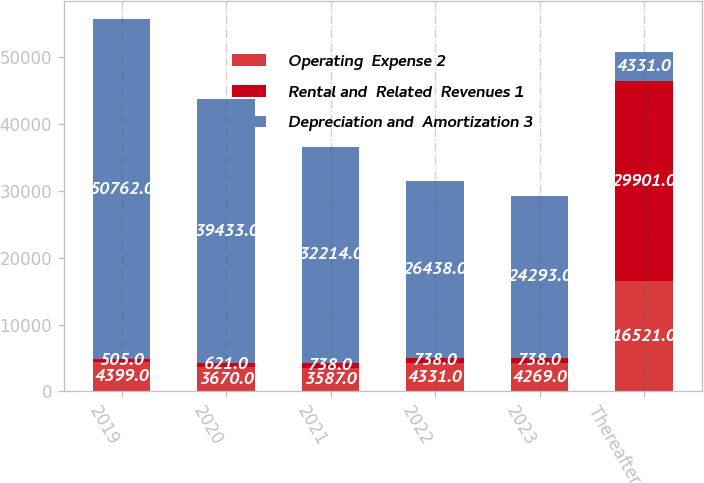Convert chart to OTSL. <chart><loc_0><loc_0><loc_500><loc_500><stacked_bar_chart><ecel><fcel>2019<fcel>2020<fcel>2021<fcel>2022<fcel>2023<fcel>Thereafter<nl><fcel>Operating  Expense 2<fcel>4399<fcel>3670<fcel>3587<fcel>4331<fcel>4269<fcel>16521<nl><fcel>Rental and  Related  Revenues 1<fcel>505<fcel>621<fcel>738<fcel>738<fcel>738<fcel>29901<nl><fcel>Depreciation and  Amortization 3<fcel>50762<fcel>39433<fcel>32214<fcel>26438<fcel>24293<fcel>4331<nl></chart> 